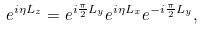Convert formula to latex. <formula><loc_0><loc_0><loc_500><loc_500>e ^ { i \eta L _ { z } } = e ^ { i \frac { \pi } { 2 } L _ { y } } e ^ { i \eta L _ { x } } e ^ { - i \frac { \pi } { 2 } L _ { y } } ,</formula> 